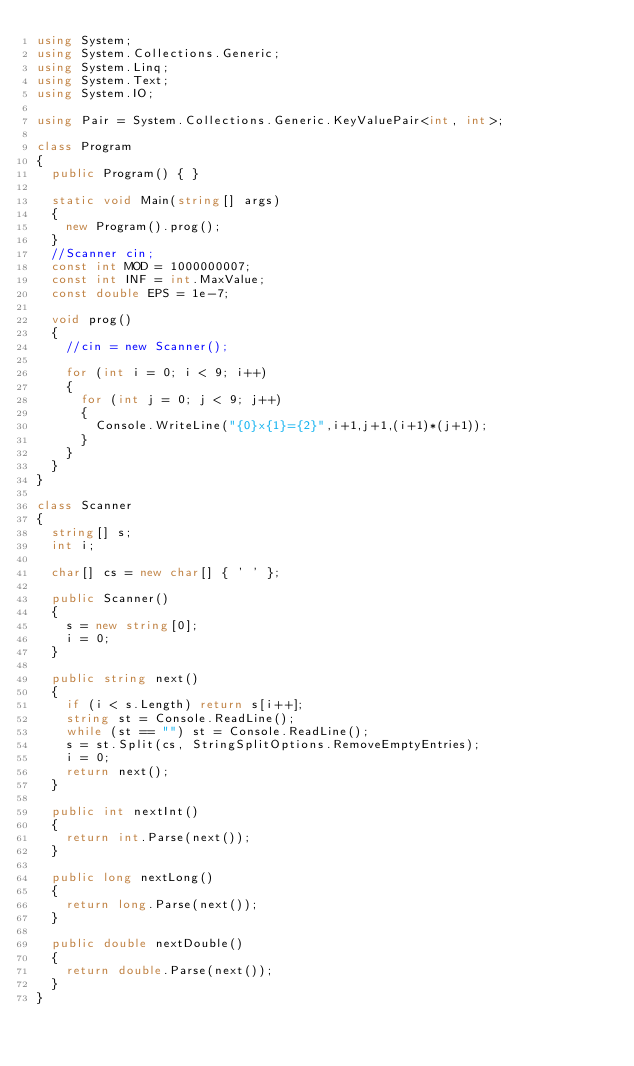Convert code to text. <code><loc_0><loc_0><loc_500><loc_500><_C#_>using System;
using System.Collections.Generic;
using System.Linq;
using System.Text;
using System.IO;

using Pair = System.Collections.Generic.KeyValuePair<int, int>;

class Program
{
	public Program() { }

	static void Main(string[] args)
	{
		new Program().prog();
	}
	//Scanner cin;
	const int MOD = 1000000007;
	const int INF = int.MaxValue;
	const double EPS = 1e-7;
	
	void prog()
	{
		//cin = new Scanner();

		for (int i = 0; i < 9; i++)
		{
			for (int j = 0; j < 9; j++)
			{
				Console.WriteLine("{0}x{1}={2}",i+1,j+1,(i+1)*(j+1));
			}
		}
	}
}

class Scanner
{
	string[] s;
	int i;

	char[] cs = new char[] { ' ' };

	public Scanner()
	{
		s = new string[0];
		i = 0;
	}

	public string next()
	{
		if (i < s.Length) return s[i++];
		string st = Console.ReadLine();
		while (st == "") st = Console.ReadLine();
		s = st.Split(cs, StringSplitOptions.RemoveEmptyEntries);
		i = 0;
		return next();
	}

	public int nextInt()
	{
		return int.Parse(next());
	}

	public long nextLong()
	{
		return long.Parse(next());
	}

	public double nextDouble()
	{
		return double.Parse(next());
	}
}</code> 